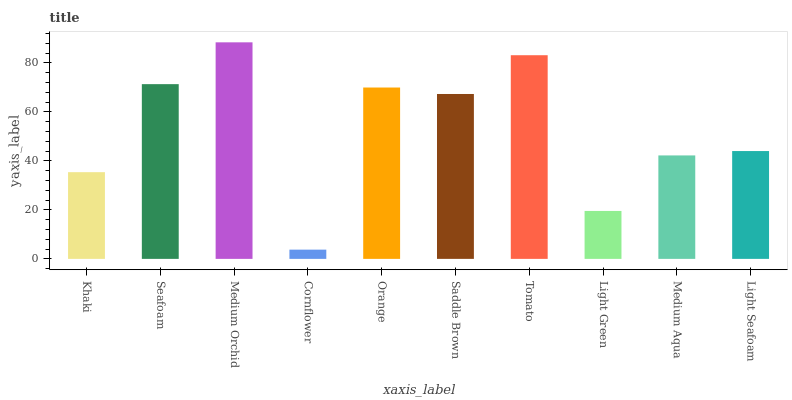Is Cornflower the minimum?
Answer yes or no. Yes. Is Medium Orchid the maximum?
Answer yes or no. Yes. Is Seafoam the minimum?
Answer yes or no. No. Is Seafoam the maximum?
Answer yes or no. No. Is Seafoam greater than Khaki?
Answer yes or no. Yes. Is Khaki less than Seafoam?
Answer yes or no. Yes. Is Khaki greater than Seafoam?
Answer yes or no. No. Is Seafoam less than Khaki?
Answer yes or no. No. Is Saddle Brown the high median?
Answer yes or no. Yes. Is Light Seafoam the low median?
Answer yes or no. Yes. Is Medium Aqua the high median?
Answer yes or no. No. Is Light Green the low median?
Answer yes or no. No. 